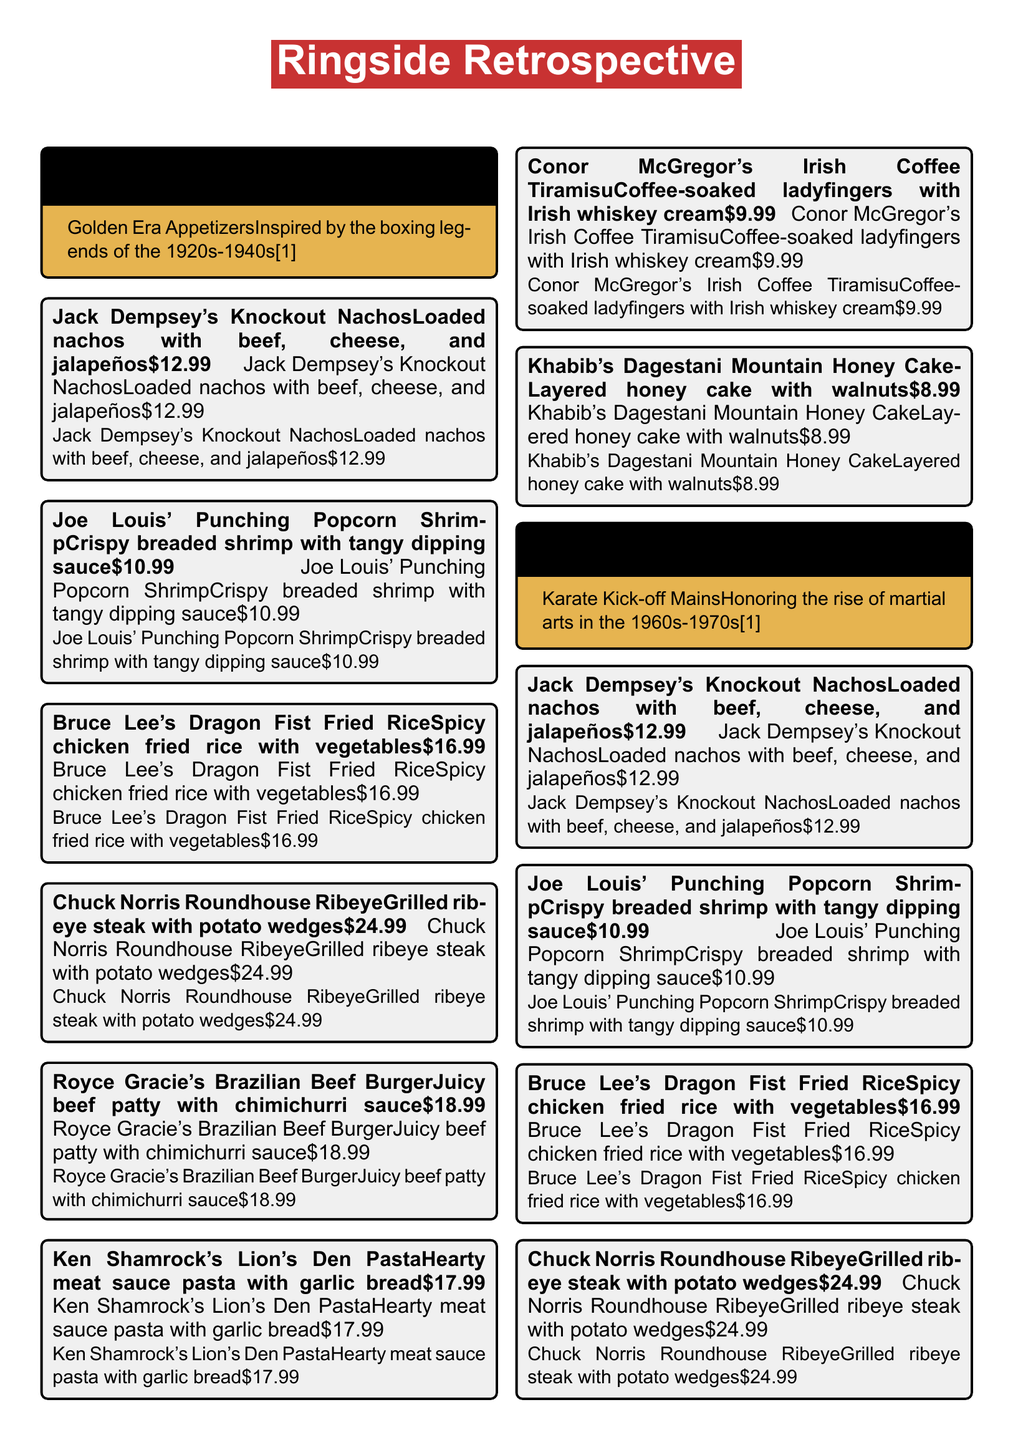What is the name of the appetizer inspired by Joe Louis? The appetizer inspired by Joe Louis is listed in the menu under appetizers and is called Joe Louis' Punching Popcorn Shrimp.
Answer: Joe Louis' Punching Popcorn Shrimp What is the price of the "Jack Dempsey's Knockout Nachos"? The price of Jack Dempsey's Knockout Nachos can be found next to the item in the menu, which is $12.99.
Answer: $12.99 Which dish represents Conor McGregor? Conor McGregor's signature dish is mentioned in the desserts section of the menu, which is called Conor McGregor's Irish Coffee Tiramisu.
Answer: Conor McGregor's Irish Coffee Tiramisu What is the main ingredient in Royce Gracie's Brazilian Beef Burger? The main ingredient in Royce Gracie's Brazilian Beef Burger is indicated in the menu and is a juicy beef patty.
Answer: Beef patty How many sections are in the menu? The menu is divided into four sections, each representing different eras of combat sports history.
Answer: Four Which dish is associated with Ken Shamrock? The dish associated with Ken Shamrock is mentioned in the mains section and is called Ken Shamrock's Lion's Den Pasta.
Answer: Ken Shamrock's Lion's Den Pasta What type of cuisine is represented in the "Khabib's Dagestani Mountain Honey Cake"? The type of cuisine represented by Khabib's Dagestani Mountain Honey Cake relates to Daghestan and is a dessert featuring layered honey cake.
Answer: Dessert What era does the "Karate Kick-off Mains" section honor? The "Karate Kick-off Mains" section honors the rise of martial arts, specifically during the 1960s-1970s era.
Answer: 1960s-1970s What is the theme of the restaurant menu? The theme of the restaurant menu is a nostalgic showcase of classic dishes inspired by various eras of combat sports history.
Answer: Nostalgic showcase 